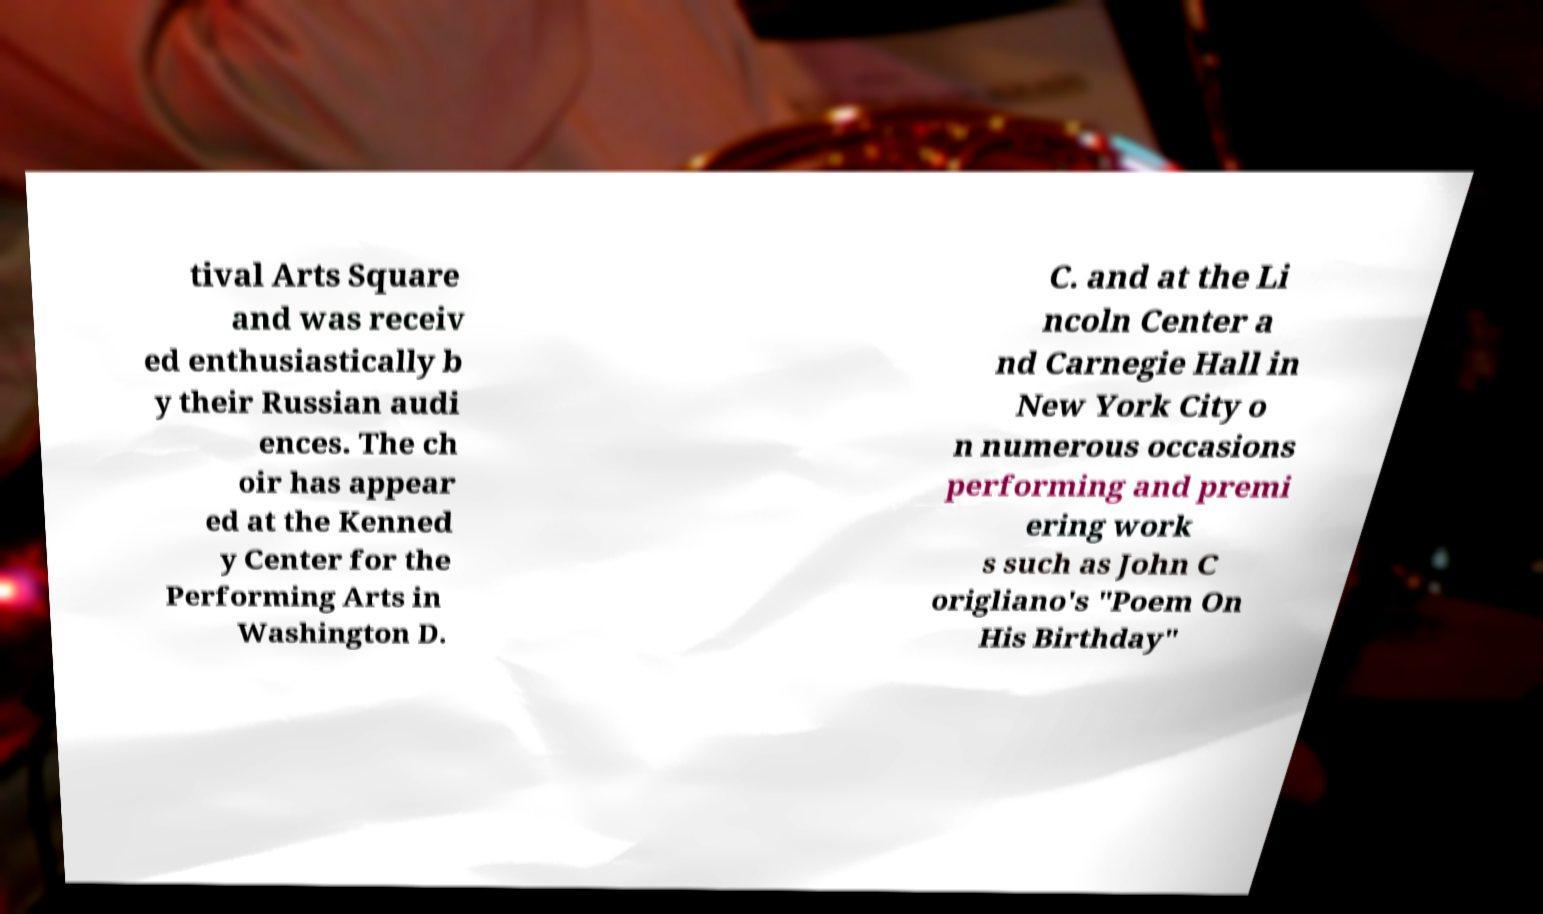Can you read and provide the text displayed in the image?This photo seems to have some interesting text. Can you extract and type it out for me? tival Arts Square and was receiv ed enthusiastically b y their Russian audi ences. The ch oir has appear ed at the Kenned y Center for the Performing Arts in Washington D. C. and at the Li ncoln Center a nd Carnegie Hall in New York City o n numerous occasions performing and premi ering work s such as John C origliano's "Poem On His Birthday" 